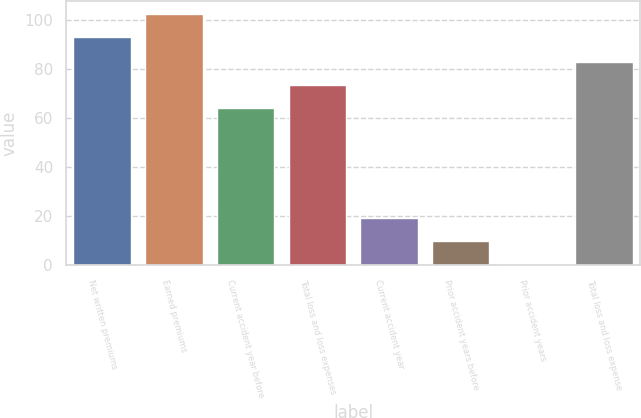Convert chart to OTSL. <chart><loc_0><loc_0><loc_500><loc_500><bar_chart><fcel>Net written premiums<fcel>Earned premiums<fcel>Current accident year before<fcel>Total loss and loss expenses<fcel>Current accident year<fcel>Prior accident years before<fcel>Prior accident years<fcel>Total loss and loss expense<nl><fcel>93<fcel>102.47<fcel>64<fcel>73.47<fcel>19.25<fcel>9.78<fcel>0.31<fcel>82.94<nl></chart> 